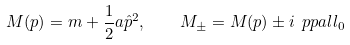Convert formula to latex. <formula><loc_0><loc_0><loc_500><loc_500>M ( p ) = m + \frac { 1 } { 2 } a \hat { p } ^ { 2 } , \quad M _ { \pm } = M ( p ) \pm i \ p p a l l _ { 0 }</formula> 